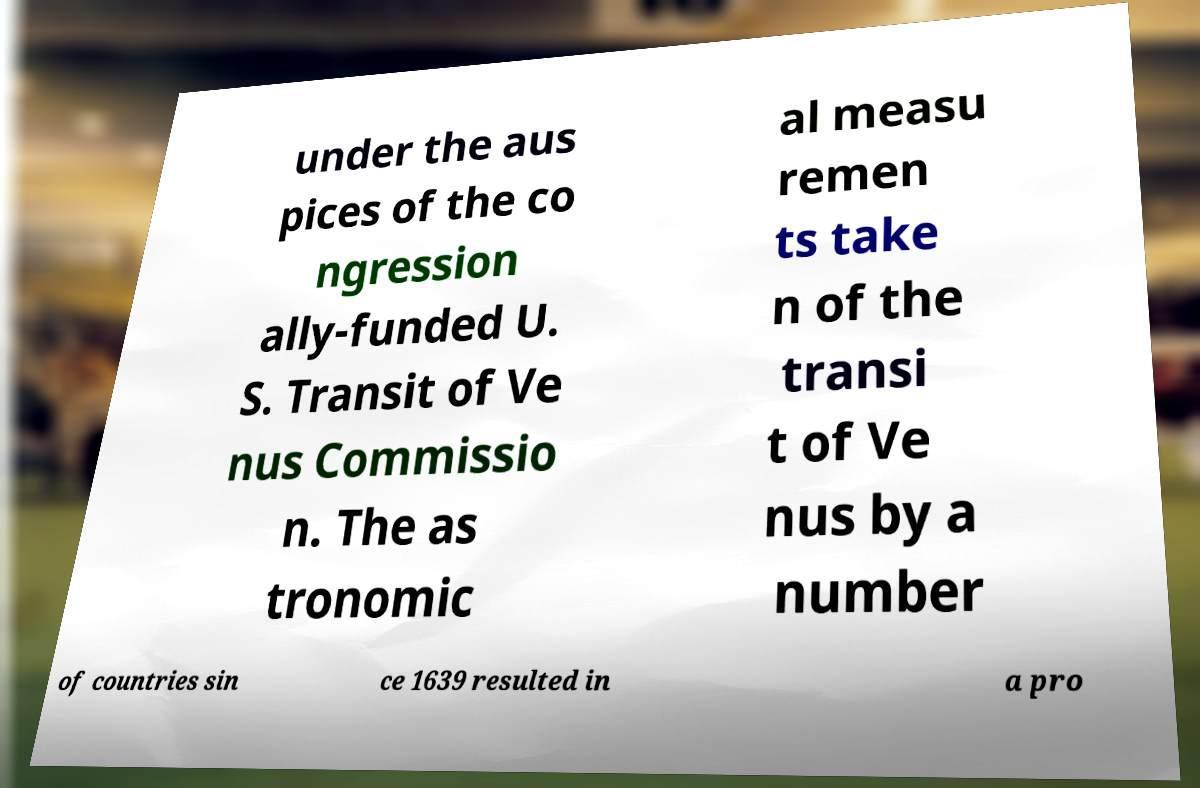For documentation purposes, I need the text within this image transcribed. Could you provide that? under the aus pices of the co ngression ally-funded U. S. Transit of Ve nus Commissio n. The as tronomic al measu remen ts take n of the transi t of Ve nus by a number of countries sin ce 1639 resulted in a pro 